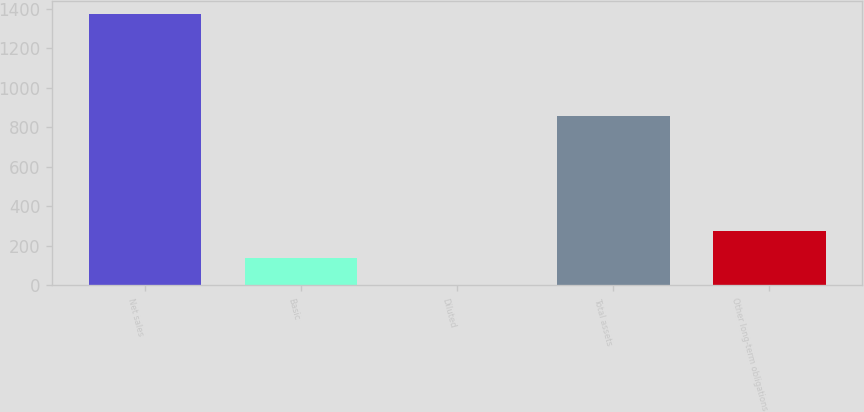<chart> <loc_0><loc_0><loc_500><loc_500><bar_chart><fcel>Net sales<fcel>Basic<fcel>Diluted<fcel>Total assets<fcel>Other long-term obligations<nl><fcel>1372.4<fcel>138.42<fcel>1.31<fcel>858.9<fcel>275.53<nl></chart> 